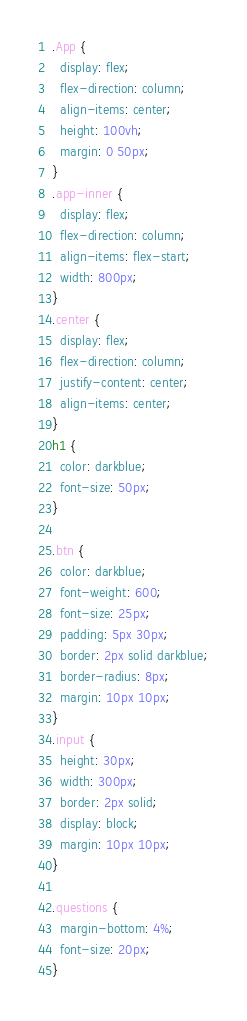<code> <loc_0><loc_0><loc_500><loc_500><_CSS_>.App {
  display: flex;
  flex-direction: column;
  align-items: center;
  height: 100vh;
  margin: 0 50px;
}
.app-inner {
  display: flex;
  flex-direction: column;
  align-items: flex-start;
  width: 800px;
}
.center {
  display: flex;
  flex-direction: column;
  justify-content: center;
  align-items: center;
}
h1 {
  color: darkblue;
  font-size: 50px;
}

.btn {
  color: darkblue;
  font-weight: 600;
  font-size: 25px;
  padding: 5px 30px;
  border: 2px solid darkblue;
  border-radius: 8px;
  margin: 10px 10px;
}
.input {
  height: 30px;
  width: 300px;
  border: 2px solid;
  display: block;
  margin: 10px 10px;
}

.questions {
  margin-bottom: 4%;
  font-size: 20px;
}
</code> 